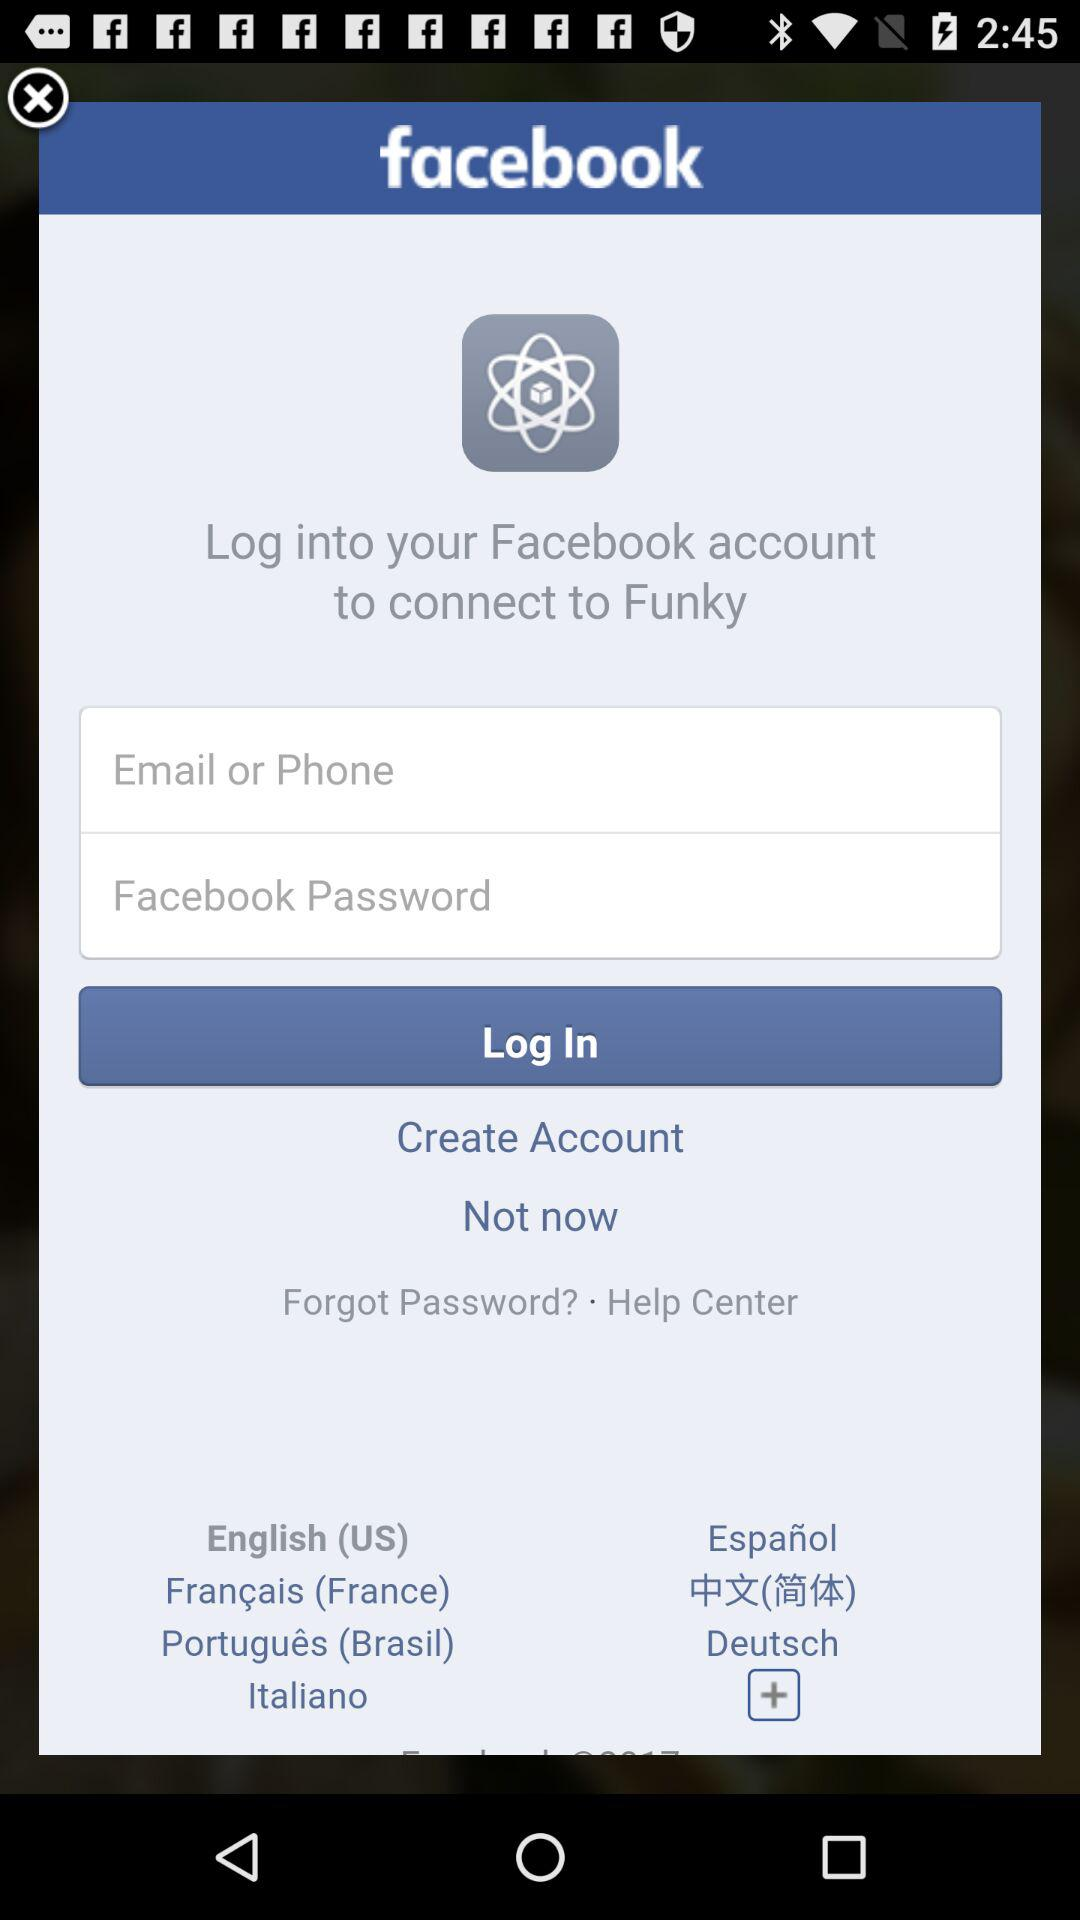What is the application name? The application names are "facebook" and "Funky". 